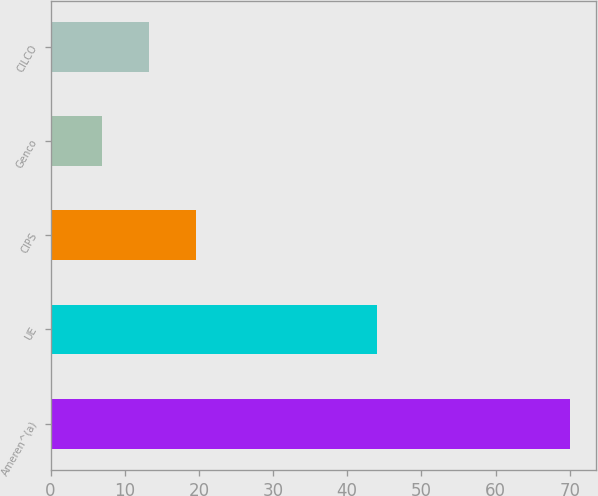Convert chart. <chart><loc_0><loc_0><loc_500><loc_500><bar_chart><fcel>Ameren^(a)<fcel>UE<fcel>CIPS<fcel>Genco<fcel>CILCO<nl><fcel>70<fcel>44<fcel>19.6<fcel>7<fcel>13.3<nl></chart> 